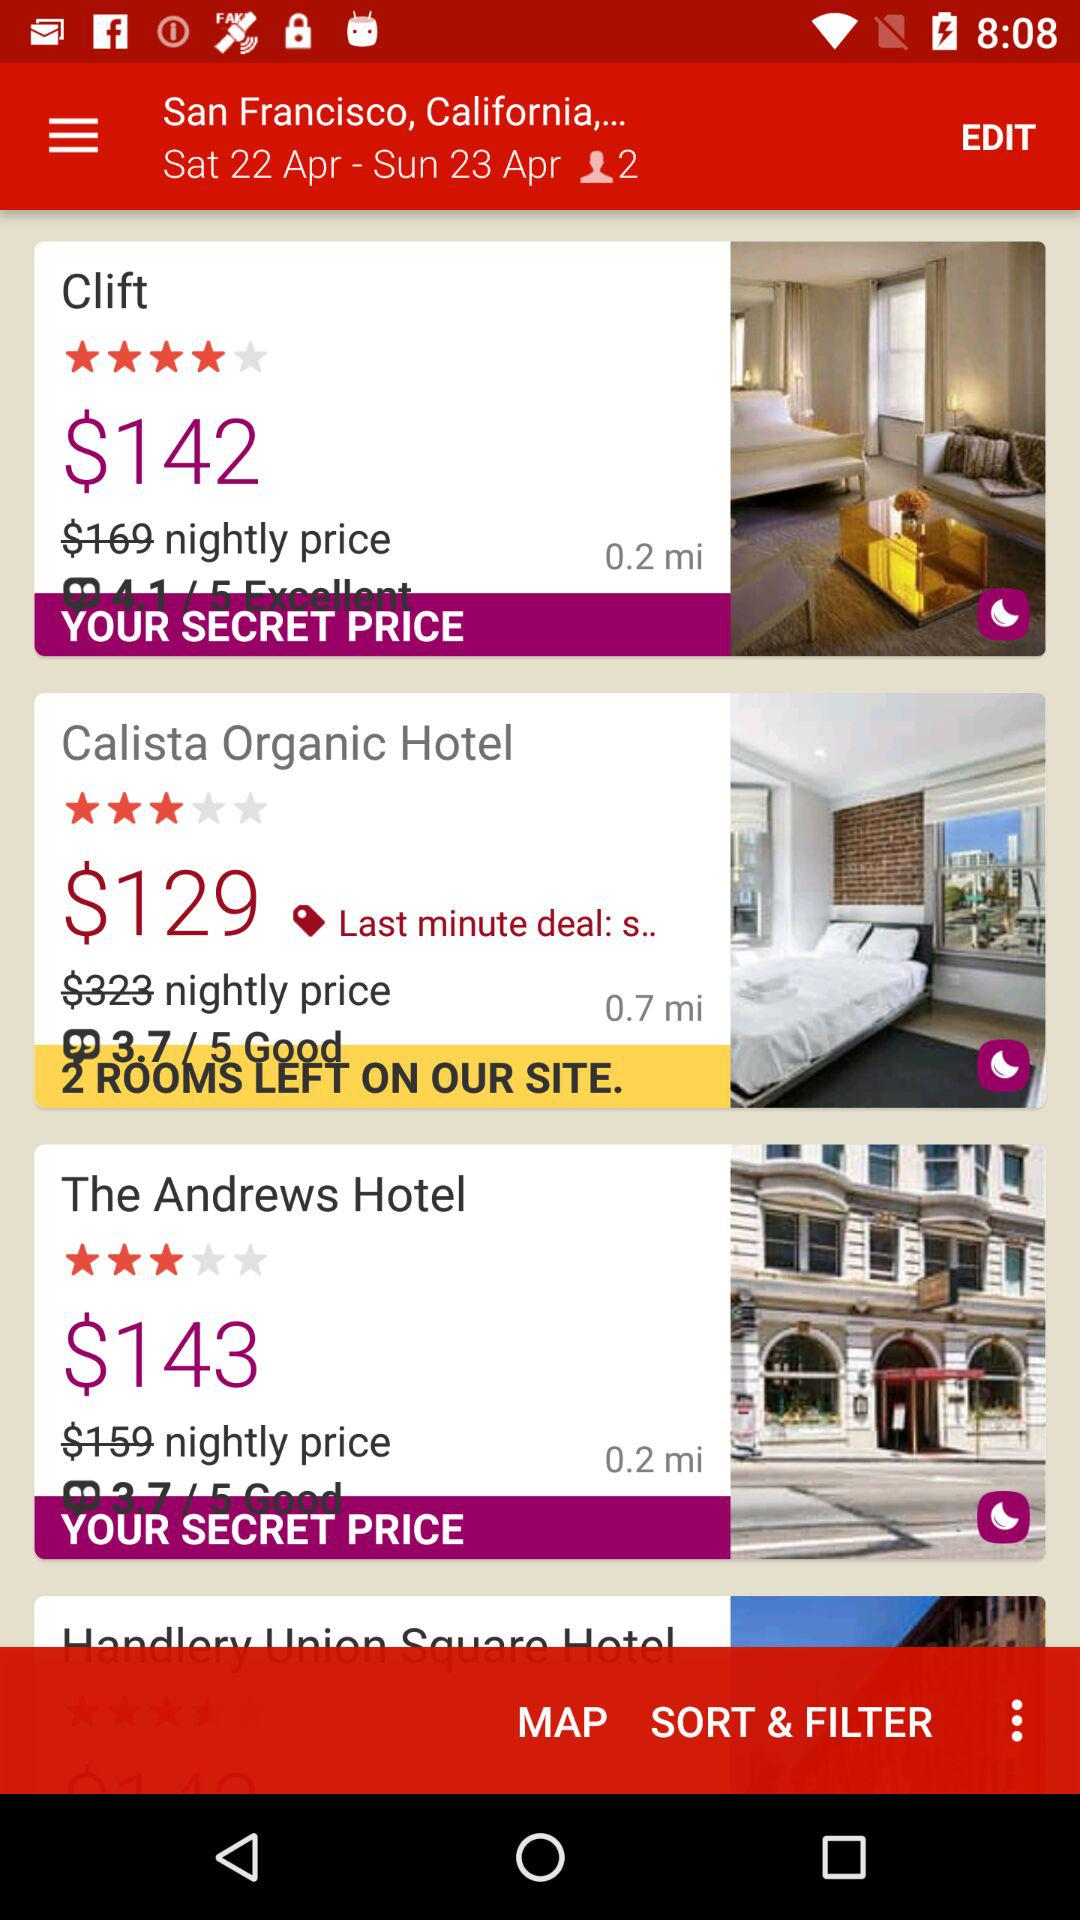What is the distance of "Clift" from my place? The distance of "Clift" from your place is 0.2 miles. 